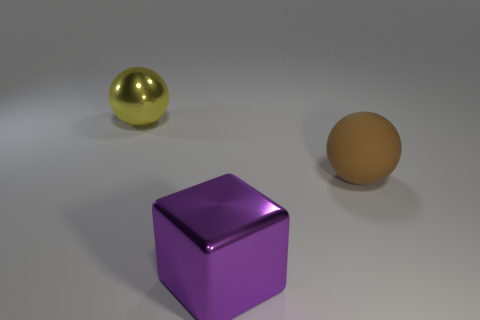Add 1 big brown things. How many objects exist? 4 Subtract all yellow spheres. How many spheres are left? 1 Subtract all red blocks. Subtract all purple cylinders. How many blocks are left? 1 Subtract all brown cubes. How many yellow balls are left? 1 Subtract all large yellow matte objects. Subtract all large balls. How many objects are left? 1 Add 1 brown matte balls. How many brown matte balls are left? 2 Add 1 big blue shiny spheres. How many big blue shiny spheres exist? 1 Subtract 0 green cylinders. How many objects are left? 3 Subtract all balls. How many objects are left? 1 Subtract 1 spheres. How many spheres are left? 1 